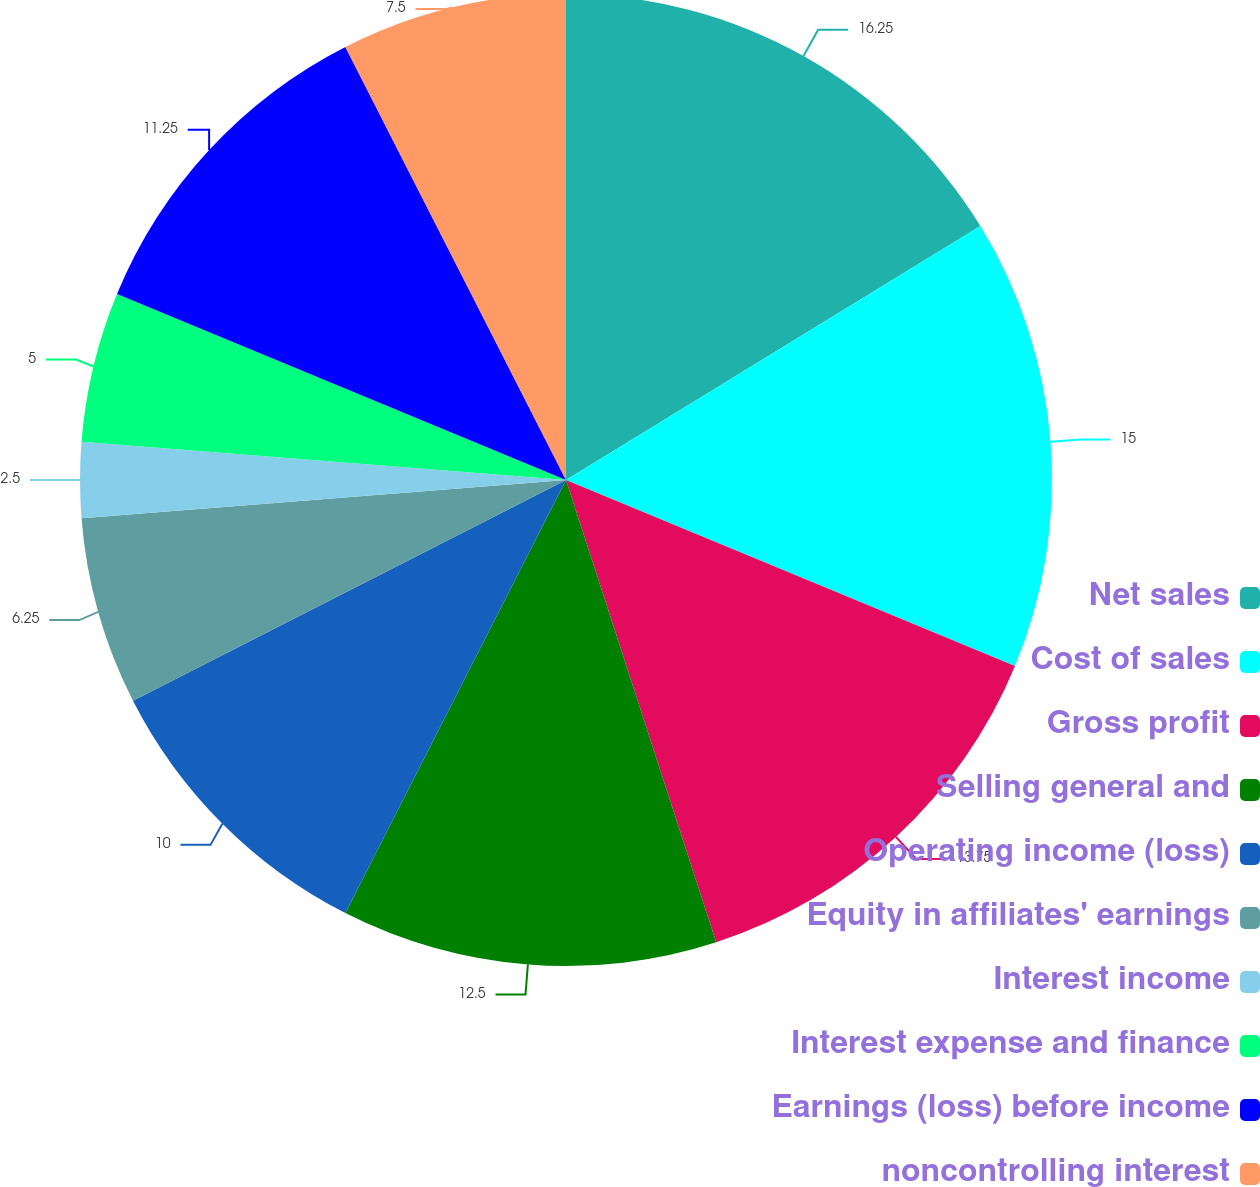Convert chart. <chart><loc_0><loc_0><loc_500><loc_500><pie_chart><fcel>Net sales<fcel>Cost of sales<fcel>Gross profit<fcel>Selling general and<fcel>Operating income (loss)<fcel>Equity in affiliates' earnings<fcel>Interest income<fcel>Interest expense and finance<fcel>Earnings (loss) before income<fcel>noncontrolling interest<nl><fcel>16.25%<fcel>15.0%<fcel>13.75%<fcel>12.5%<fcel>10.0%<fcel>6.25%<fcel>2.5%<fcel>5.0%<fcel>11.25%<fcel>7.5%<nl></chart> 